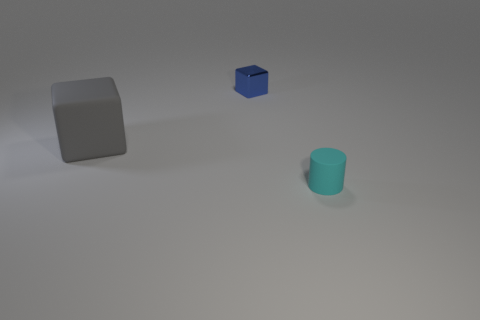Add 3 tiny brown matte blocks. How many objects exist? 6 Subtract all gray cubes. How many cubes are left? 1 Subtract all cylinders. How many objects are left? 2 Subtract all red cylinders. Subtract all gray balls. How many cylinders are left? 1 Subtract all blue cylinders. How many cyan cubes are left? 0 Subtract all large blue shiny objects. Subtract all large gray blocks. How many objects are left? 2 Add 1 gray rubber cubes. How many gray rubber cubes are left? 2 Add 1 cyan rubber things. How many cyan rubber things exist? 2 Subtract 0 purple cylinders. How many objects are left? 3 